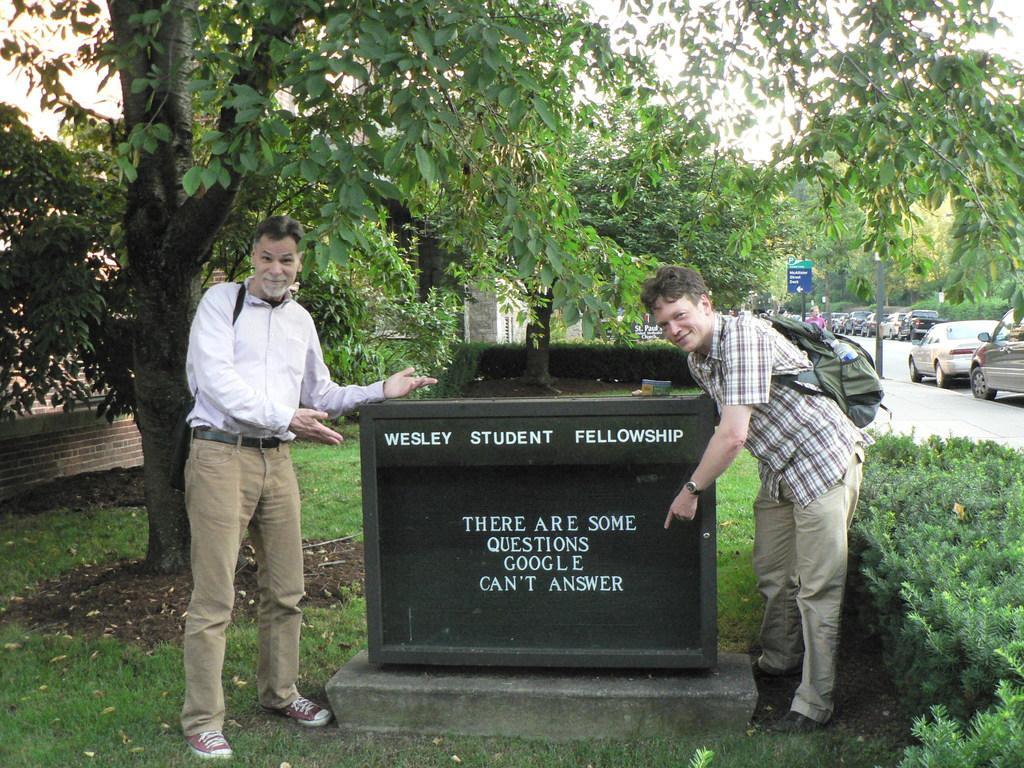How would you summarize this image in a sentence or two? In this image we can see men standing on the ground, shredded leaves, bushes, motor vehicles on the road, sign boards, information boards, trees, buildings and sky. 